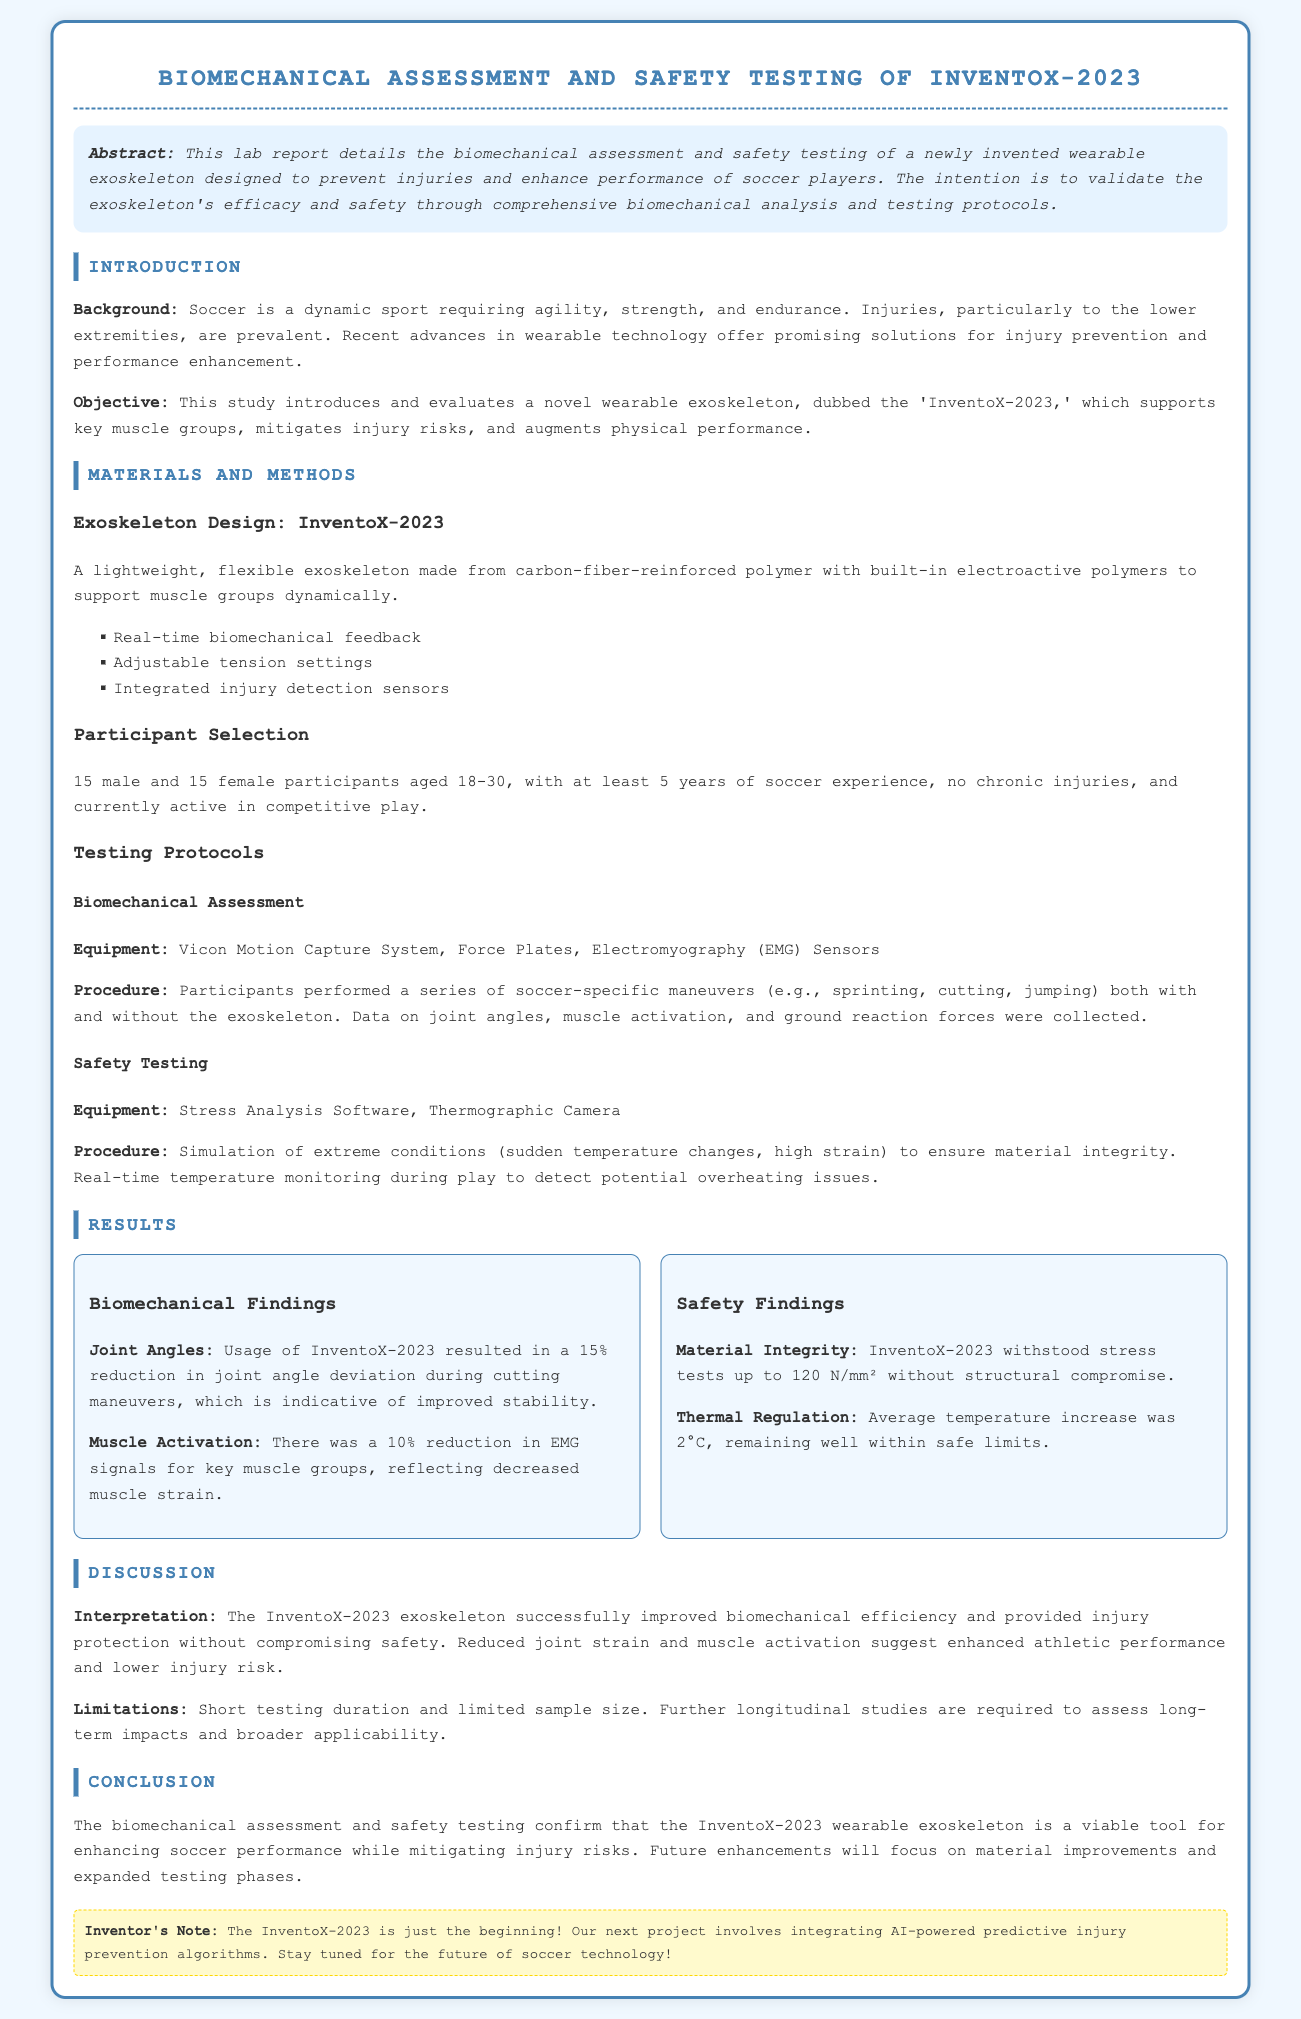What is the title of the lab report? The title of the lab report is prominently displayed at the top of the document.
Answer: Biomechanical Assessment and Safety Testing of InventoX-2023 What materials were used in the exoskeleton? The materials used in the exoskeleton are listed in the design section.
Answer: Carbon-fiber-reinforced polymer How many male participants were involved in the study? The participant selection section specifies the number of male participants.
Answer: 15 What was the average temperature increase during safety testing? The safety findings section mentions the average temperature increase observed.
Answer: 2°C What was the joint angle deviation reduction during cutting maneuvers? The biomechanical findings section provides specific results regarding joint angle deviation.
Answer: 15% What kind of sensors are integrated into the exoskeleton? The materials and methods section lists the features of the exoskeleton, including sensors.
Answer: Injury detection sensors What is the maximum stress the exoskeleton withstood during testing? The safety findings section reports the maximum stress tested on the exoskeleton.
Answer: 120 N/mm² What future project is mentioned in the inventor's note? The inventor's note highlights the next project following the current exoskeleton.
Answer: AI-powered predictive injury prevention algorithms What percentage reduction in EMG signals was recorded? The biomechanical findings section indicates the percentage reduction in muscle activation measured by EMG.
Answer: 10% 